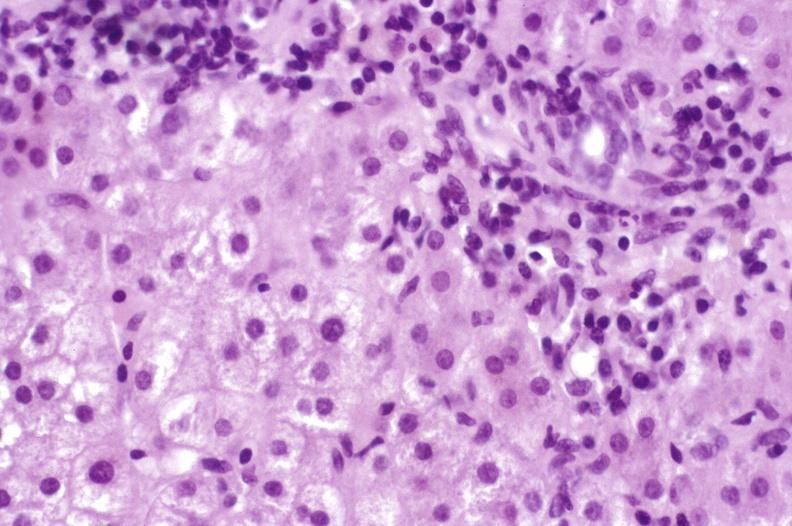does stein leventhal show primary biliary cirrhosis?
Answer the question using a single word or phrase. No 